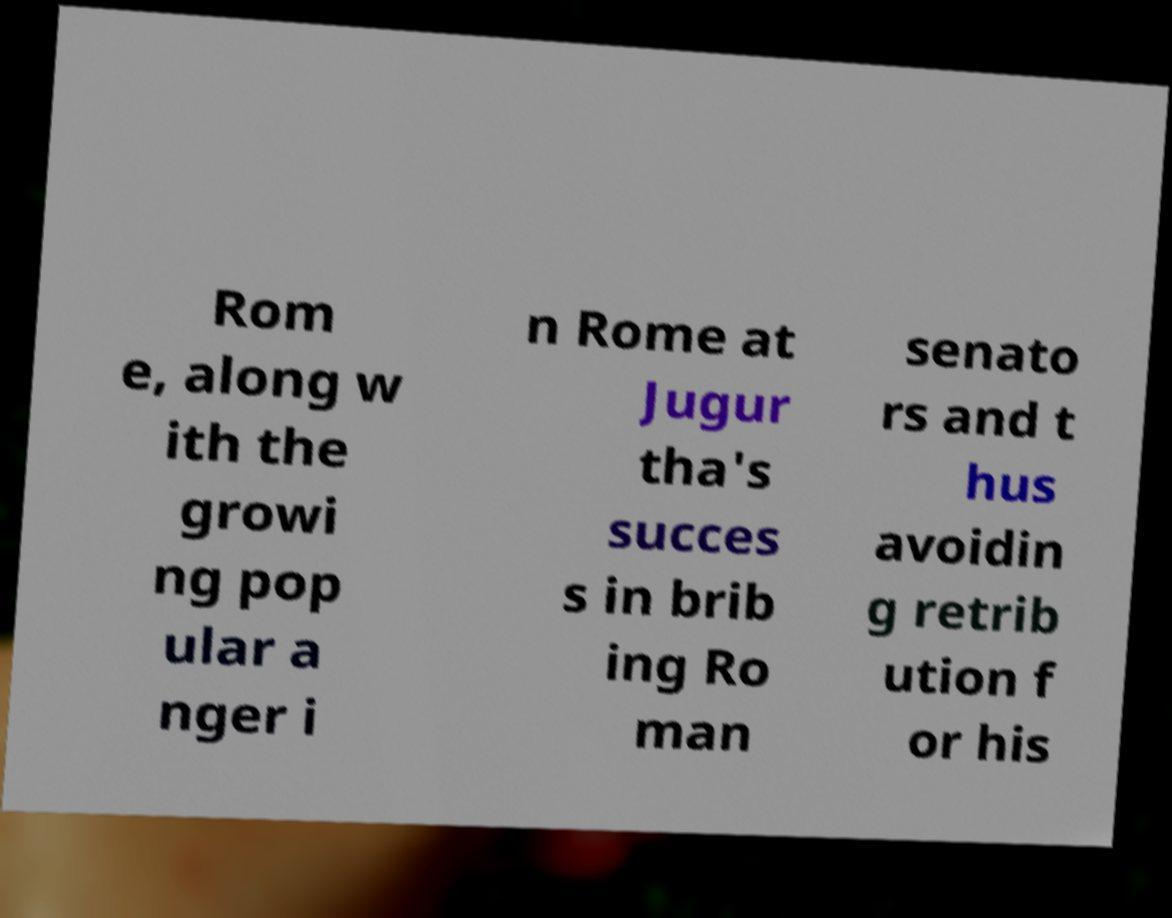I need the written content from this picture converted into text. Can you do that? Rom e, along w ith the growi ng pop ular a nger i n Rome at Jugur tha's succes s in brib ing Ro man senato rs and t hus avoidin g retrib ution f or his 